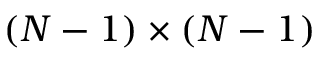<formula> <loc_0><loc_0><loc_500><loc_500>( N - 1 ) \times ( N - 1 )</formula> 